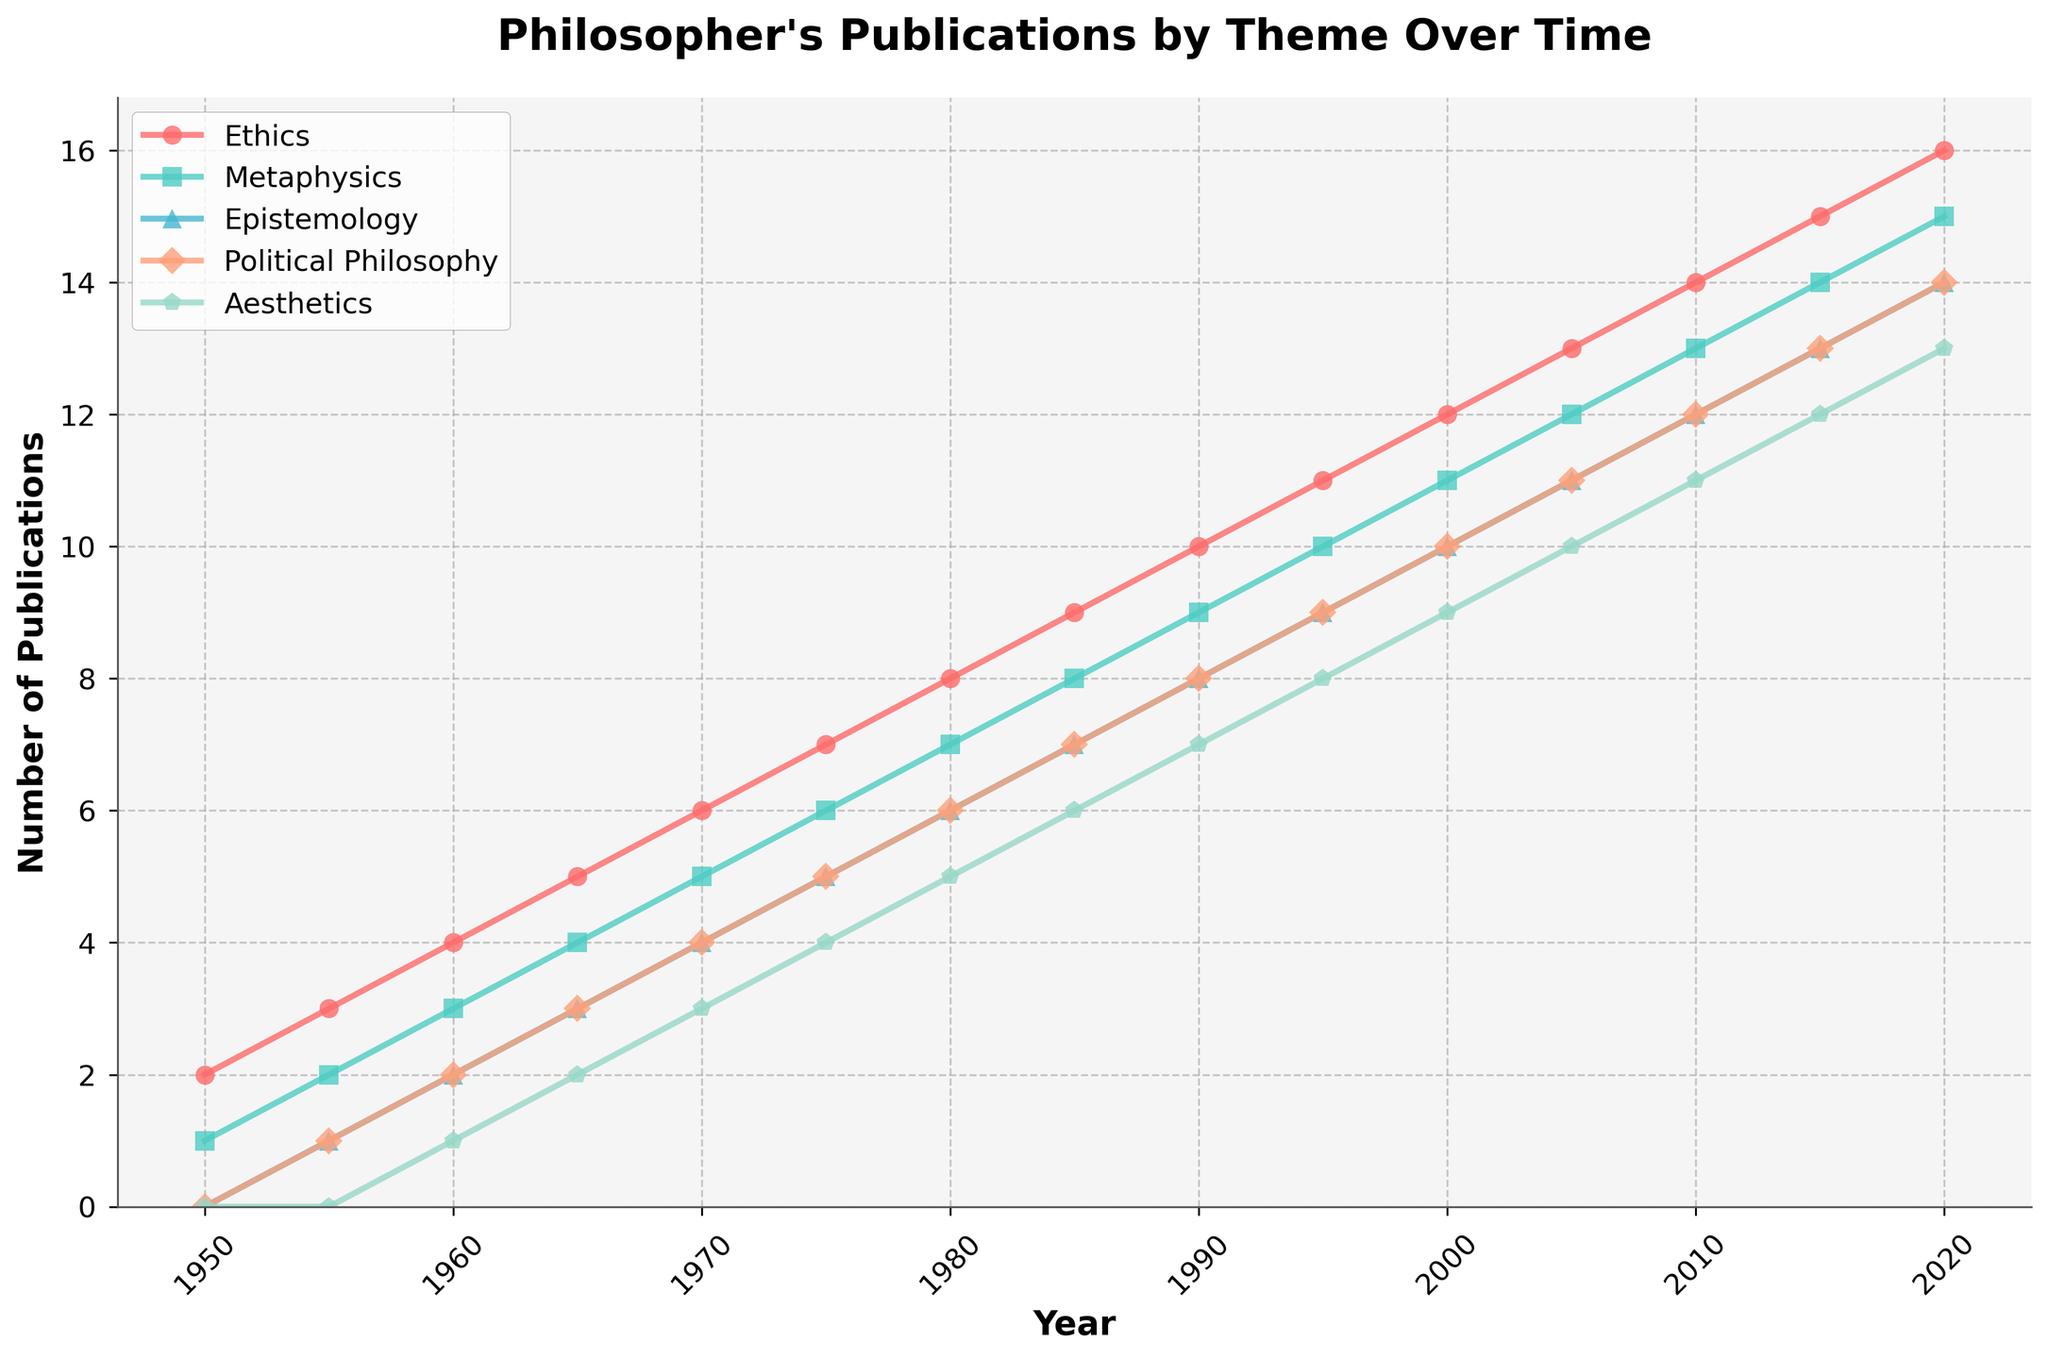When did the philosopher have the highest number of publications in Ethics? The line for Ethics is the top-most and the steepest towards the end of the timeline. Observing the plot, the highest point for Ethics is in the year 2020.
Answer: 2020 Which theme had the lowest number of publications in 1985? By looking at the data points corresponding to the year 1985, the theme that had the lowest publication count is Aesthetics.
Answer: Aesthetics How many total publications were there in 2010 across all themes? To find the total publications in 2010, sum the values from all themes in that year: Ethics (14) + Metaphysics (13) + Epistemology (12) + Political Philosophy (12) + Aesthetics (11).
Answer: 62 In which year did the philosopher publish an equal number of works in both Metaphysics and Epistemology? By comparing the data points visually for Metaphysics and Epistemology, identify the year where the lines intersect at the same value. This occurs in 1970.
Answer: 1970 Across the entire period, which theme showed the greatest overall increase in publications? By subtracting the initial values from the final values for each theme: Ethics (16-2 = 14), Metaphysics (15-1 = 14), Epistemology (14-0 = 14), Political Philosophy (14-0 = 14), Aesthetics (13-0 = 13), we find that the greatest increase is shared by Ethics, Metaphysics, Epistemology, and Political Philosophy.
Answer: Ethics/Metaphysics/Epistemology/Political Philosophy What is the average number of publications in Political Philosophy from 1950 to 2020? Sum up the number of publications in Political Philosophy across all the years and divide by the number of years (15). Total: 0+1+2+3+4+5+6+7+8+9+10+11+12+13+14 = 105, so average is 105/15.
Answer: 7 Which theme had the second highest number of publications in 1995? By inspecting the data points for the year 1995, the second highest number of publications is in Metaphysics.
Answer: Metaphysics By how much did the number of publications in Epistemology grow from 1960 to 2000? To calculate the growth, subtract the number of publications in 1960 from those in 2000: 10 - 2 = 10.
Answer: 8 In which year did the number of publications in Aesthetics surpass those in Epistemology for the first time? By observing the data trajectories, the year when Aesthetics surpasses Epistemology for the first time is 2010.
Answer: 2010 